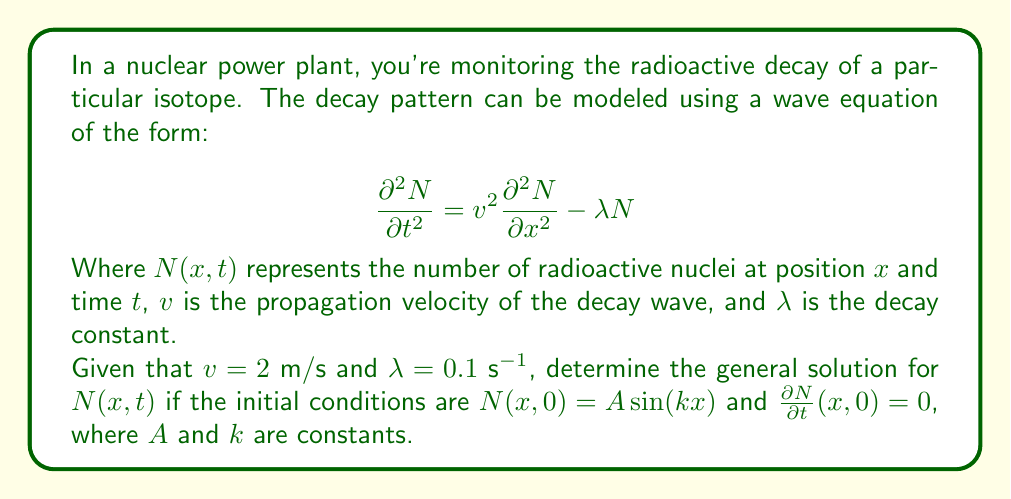Can you solve this math problem? To solve this problem, we'll follow these steps:

1) The general solution for this type of wave equation is of the form:

   $$N(x,t) = e^{-\frac{\lambda t}{2}}[f(x-vt) + g(x+vt)]$$

   Where $f$ and $g$ are arbitrary functions.

2) Given the initial condition $N(x,0) = A\sin(kx)$, we can write:

   $$A\sin(kx) = f(x) + g(x)$$

3) The second initial condition $\frac{\partial N}{\partial t}(x,0) = 0$ gives us:

   $$0 = -\frac{\lambda}{2}[f(x) + g(x)] - vf'(x) + vg'(x)$$

4) From steps 2 and 3, we can deduce:

   $$f(x) = g(x) = \frac{A}{2}\sin(kx)$$

5) Substituting these into the general solution:

   $$N(x,t) = e^{-\frac{\lambda t}{2}}[\frac{A}{2}\sin(k(x-vt)) + \frac{A}{2}\sin(k(x+vt))]$$

6) Using the trigonometric identity for the sum of sines:

   $$N(x,t) = Ae^{-\frac{\lambda t}{2}}\sin(kx)\cos(kvt)$$

7) Substituting the given values $v = 2$ m/s and $\lambda = 0.1$ s^(-1):

   $$N(x,t) = Ae^{-0.05t}\sin(kx)\cos(2kt)$$

This is the general solution for the given wave equation and initial conditions.
Answer: $N(x,t) = Ae^{-0.05t}\sin(kx)\cos(2kt)$ 